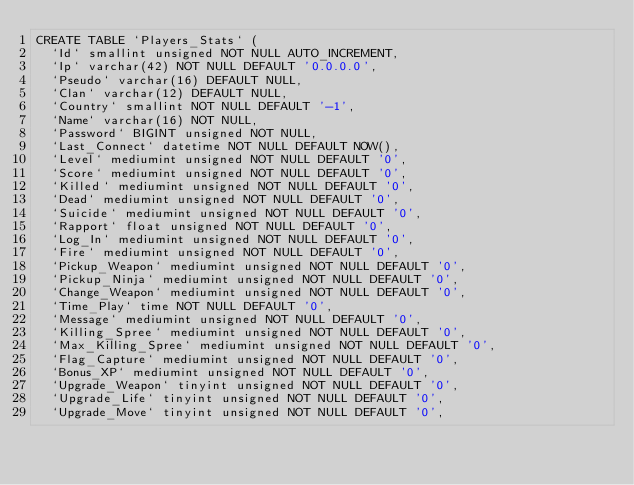Convert code to text. <code><loc_0><loc_0><loc_500><loc_500><_SQL_>CREATE TABLE `Players_Stats` (
  `Id` smallint unsigned NOT NULL AUTO_INCREMENT,
  `Ip` varchar(42) NOT NULL DEFAULT '0.0.0.0',
  `Pseudo` varchar(16) DEFAULT NULL,
  `Clan` varchar(12) DEFAULT NULL,
  `Country` smallint NOT NULL DEFAULT '-1',
  `Name` varchar(16) NOT NULL,
  `Password` BIGINT unsigned NOT NULL,
  `Last_Connect` datetime NOT NULL DEFAULT NOW(),
  `Level` mediumint unsigned NOT NULL DEFAULT '0',
  `Score` mediumint unsigned NOT NULL DEFAULT '0',
  `Killed` mediumint unsigned NOT NULL DEFAULT '0',
  `Dead` mediumint unsigned NOT NULL DEFAULT '0',
  `Suicide` mediumint unsigned NOT NULL DEFAULT '0',
  `Rapport` float unsigned NOT NULL DEFAULT '0',
  `Log_In` mediumint unsigned NOT NULL DEFAULT '0',
  `Fire` mediumint unsigned NOT NULL DEFAULT '0',
  `Pickup_Weapon` mediumint unsigned NOT NULL DEFAULT '0',
  `Pickup_Ninja` mediumint unsigned NOT NULL DEFAULT '0',
  `Change_Weapon` mediumint unsigned NOT NULL DEFAULT '0',
  `Time_Play` time NOT NULL DEFAULT '0',
  `Message` mediumint unsigned NOT NULL DEFAULT '0',
  `Killing_Spree` mediumint unsigned NOT NULL DEFAULT '0',
  `Max_Killing_Spree` mediumint unsigned NOT NULL DEFAULT '0',
  `Flag_Capture` mediumint unsigned NOT NULL DEFAULT '0',
  `Bonus_XP` mediumint unsigned NOT NULL DEFAULT '0',
  `Upgrade_Weapon` tinyint unsigned NOT NULL DEFAULT '0',
  `Upgrade_Life` tinyint unsigned NOT NULL DEFAULT '0',
  `Upgrade_Move` tinyint unsigned NOT NULL DEFAULT '0',</code> 